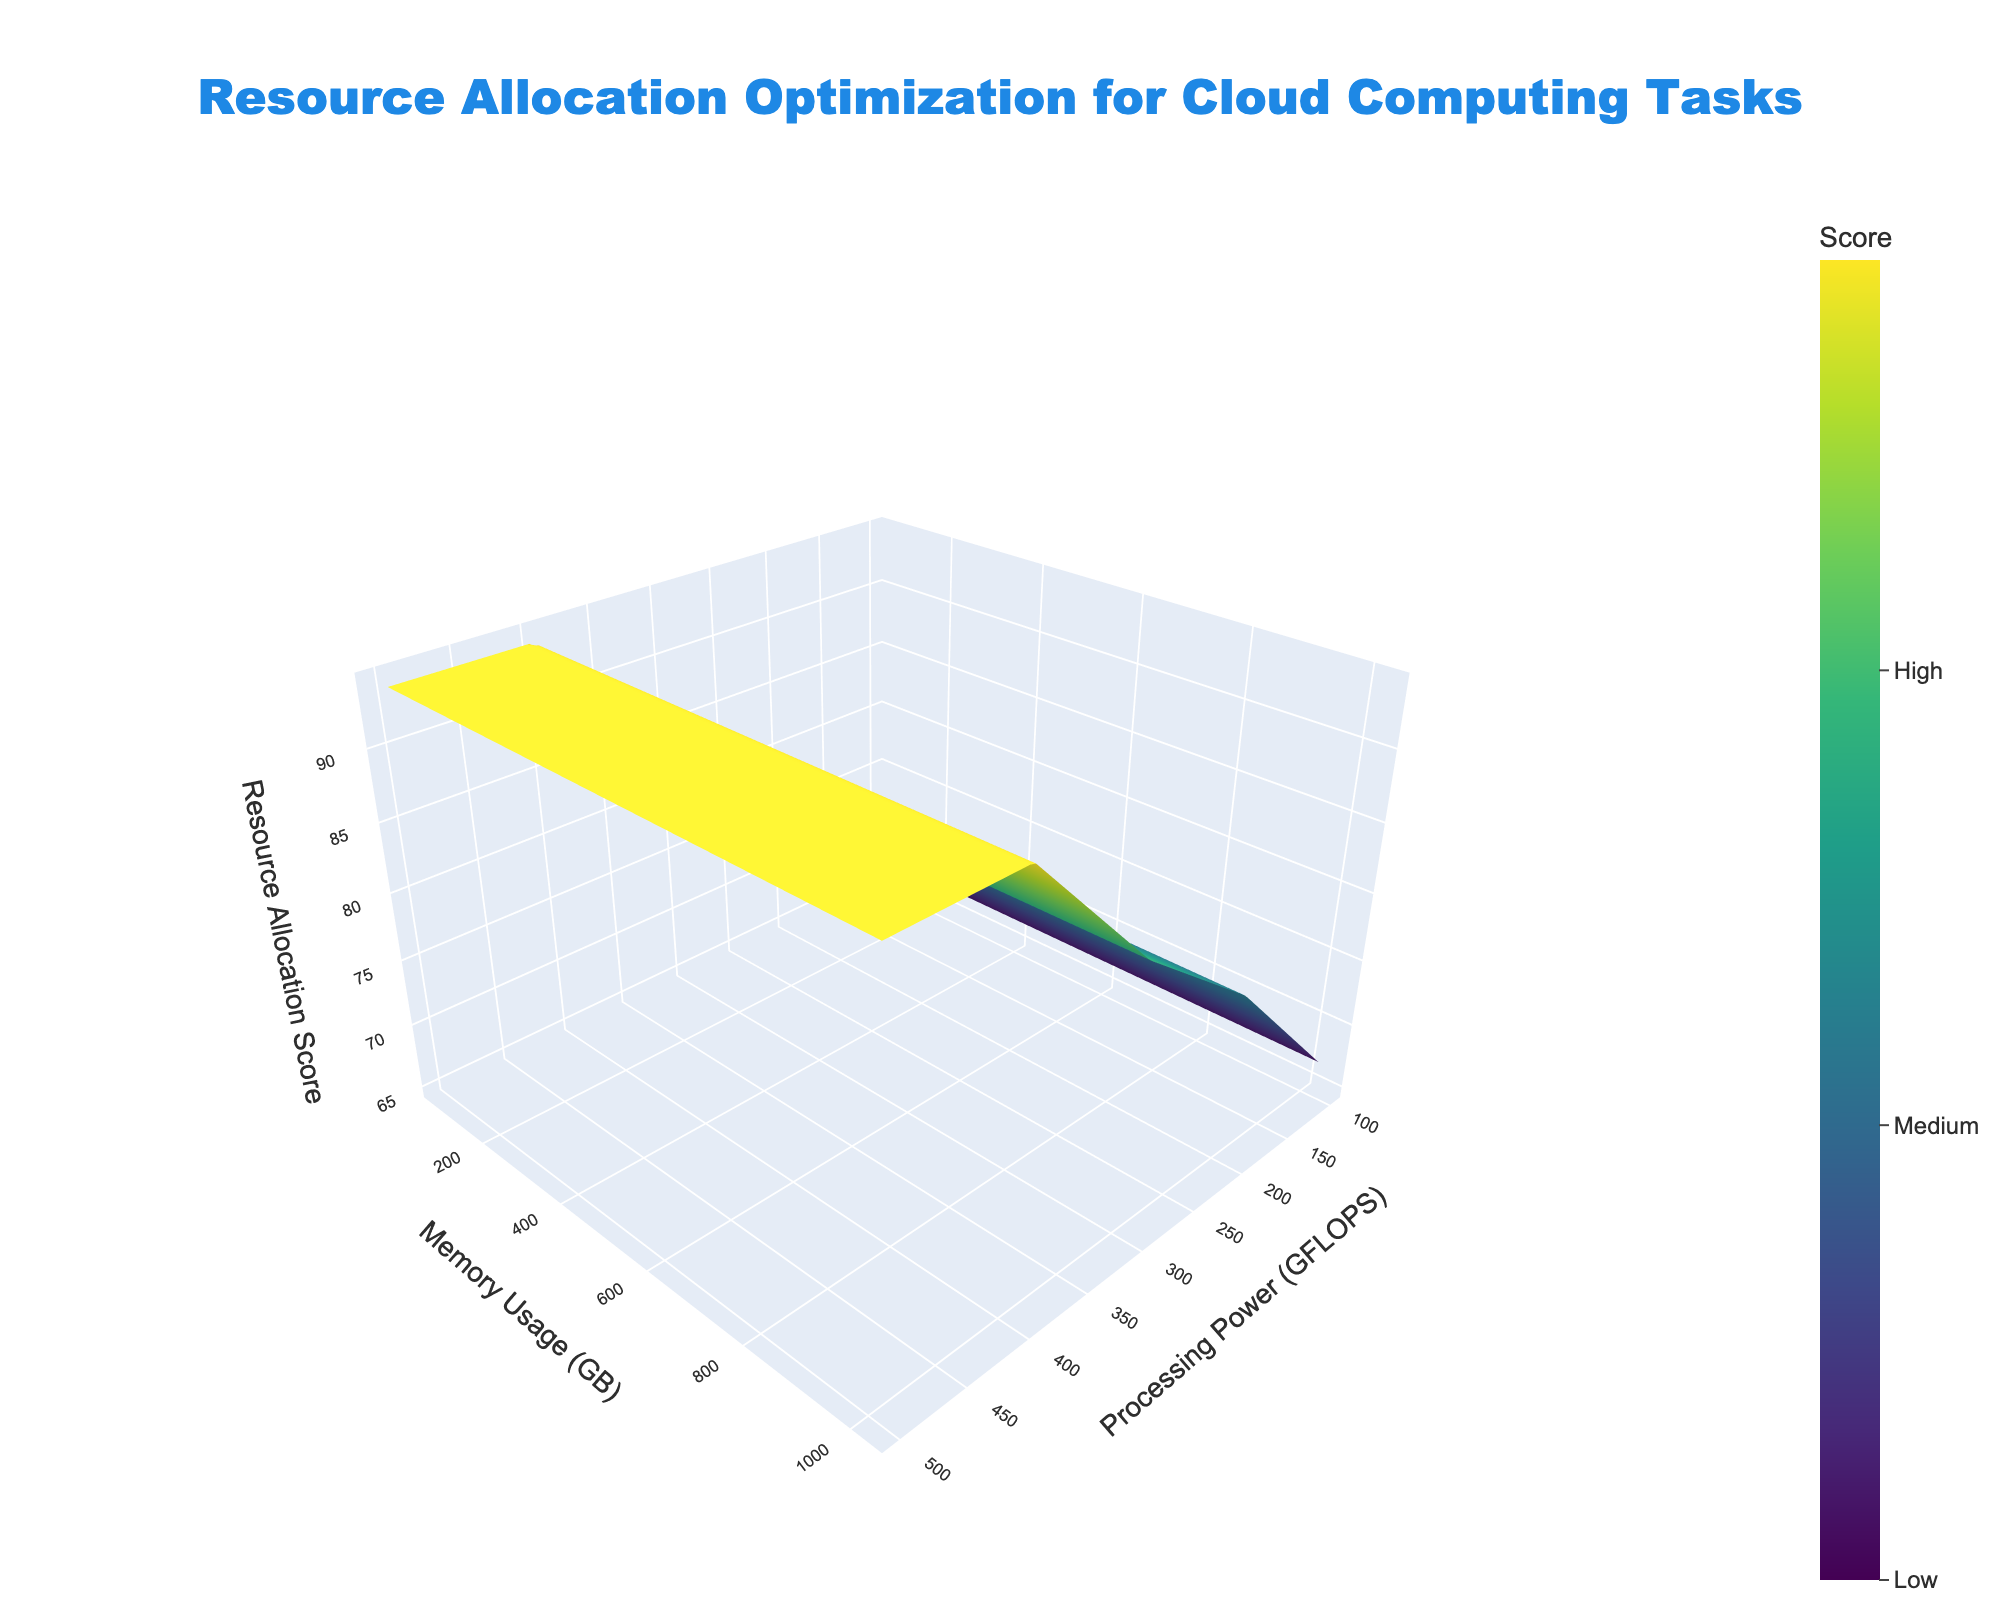What is the title of the 3D surface plot? The title is prominently displayed at the top of the plot. It reads "Resource Allocation Optimization for Cloud Computing Tasks."
Answer: Resource Allocation Optimization for Cloud Computing Tasks What are the x-axis, y-axis, and z-axis representing? The axes are labeled with their respective titles. The x-axis represents "Processing Power (GFLOPS)", the y-axis represents "Memory Usage (GB)", and the z-axis represents "Resource Allocation Score."
Answer: Processing Power (GFLOPS), Memory Usage (GB), Resource Allocation Score What is the color range used in the 3D surface plot, and what do these colors represent? The color bar on the right side of the plot shows a gradient from a lighter to a darker shade. This gradient represents the Resource Allocation Score, where lighter colors indicate lower scores and darker colors indicate higher scores. The specific ticks are labeled from "Low" to "Excellent."
Answer: Low to Excellent How does the Resource Allocation Score change with increasing Processing Power and Memory Usage? By examining the plot's surface, it becomes apparent that as both Processing Power and Memory Usage increase, the Resource Allocation Score also increases, generally moving from lighter to darker colors which suggest higher scores.
Answer: It increases Is there a point where the Resource Allocation Score is at its maximum? The highest point on the z-axis corresponds to the darkest shade on the plot, indicating the maximum Resource Allocation Score. This is observed at the highest values for both Processing Power and Memory Usage.
Answer: Yes, at highest Processing Power and Memory Usage How does the Resource Allocation Score compare when Processing Power is 200 GFLOPS with Memory Usage of 256 GB vs. 512 GB? By observing the surface, you can see that at 200 GFLOPS, the Resource Allocation Score is higher when Memory Usage is 512 GB compared to 256 GB, indicated by a darker shade.
Answer: Higher at 512 GB At what approximate values of Processing Power and Memory Usage does the Resource Allocation Score begin to level off? Observing the plot, the surface begins to level off and the Resource Allocation Score maximizes when Processing Power is around 400 GFLOPS and Memory Usage is around 512 GB.
Answer: Around 400 GFLOPS and 512 GB Are there any sudden drops in the Resource Allocation Score at certain points? The plot is fairly smooth without any abrupt changes in the surface, indicating a gradual change in Resource Allocation Score without sudden drops in the score.
Answer: No sudden drops How would increasing Processing Power from 300 GFLOPS to 400 GFLOPS, while keeping Memory Usage constant at 256 GB, affect the Resource Allocation Score? From observing the surface color gradient, increasing Processing Power from 300 to 400 GFLOPS at a constant Memory Usage of 256 GB leads to a higher Resource Allocation Score, as indicated by a darker shade.
Answer: The score increases What's the general trend in the Resource Allocation Score when increasing Memory Usage while keeping Processing Power constant at 500 GFLOPS? Observing the height and color changes on the surface plot, the Resource Allocation Score generally increases as Memory Usage increases, shown by the darkening of color at 500 GFLOPS.
Answer: It increases 